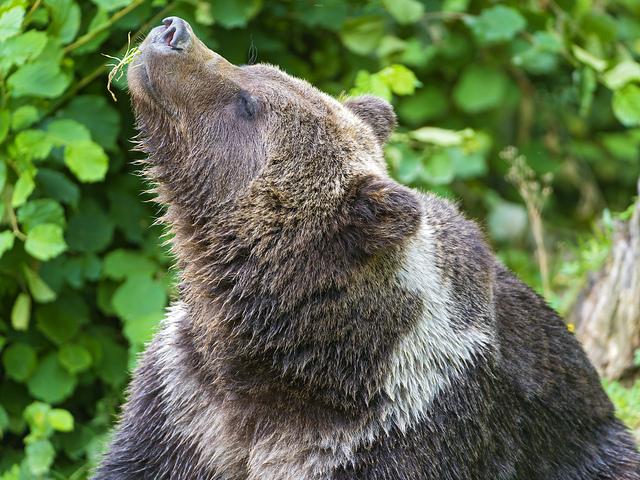Is the bear's eye open or closed?
Keep it brief. Closed. What country is bear in?
Answer briefly. United states. What color stripe is around the bear's neck?
Keep it brief. White. 